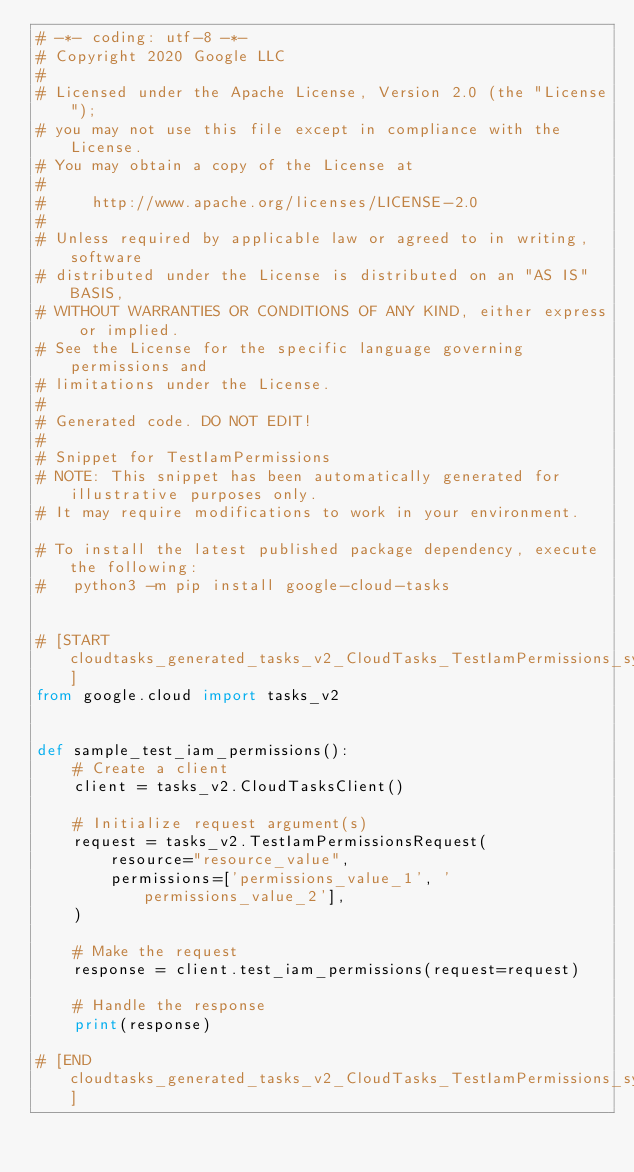Convert code to text. <code><loc_0><loc_0><loc_500><loc_500><_Python_># -*- coding: utf-8 -*-
# Copyright 2020 Google LLC
#
# Licensed under the Apache License, Version 2.0 (the "License");
# you may not use this file except in compliance with the License.
# You may obtain a copy of the License at
#
#     http://www.apache.org/licenses/LICENSE-2.0
#
# Unless required by applicable law or agreed to in writing, software
# distributed under the License is distributed on an "AS IS" BASIS,
# WITHOUT WARRANTIES OR CONDITIONS OF ANY KIND, either express or implied.
# See the License for the specific language governing permissions and
# limitations under the License.
#
# Generated code. DO NOT EDIT!
#
# Snippet for TestIamPermissions
# NOTE: This snippet has been automatically generated for illustrative purposes only.
# It may require modifications to work in your environment.

# To install the latest published package dependency, execute the following:
#   python3 -m pip install google-cloud-tasks


# [START cloudtasks_generated_tasks_v2_CloudTasks_TestIamPermissions_sync]
from google.cloud import tasks_v2


def sample_test_iam_permissions():
    # Create a client
    client = tasks_v2.CloudTasksClient()

    # Initialize request argument(s)
    request = tasks_v2.TestIamPermissionsRequest(
        resource="resource_value",
        permissions=['permissions_value_1', 'permissions_value_2'],
    )

    # Make the request
    response = client.test_iam_permissions(request=request)

    # Handle the response
    print(response)

# [END cloudtasks_generated_tasks_v2_CloudTasks_TestIamPermissions_sync]
</code> 